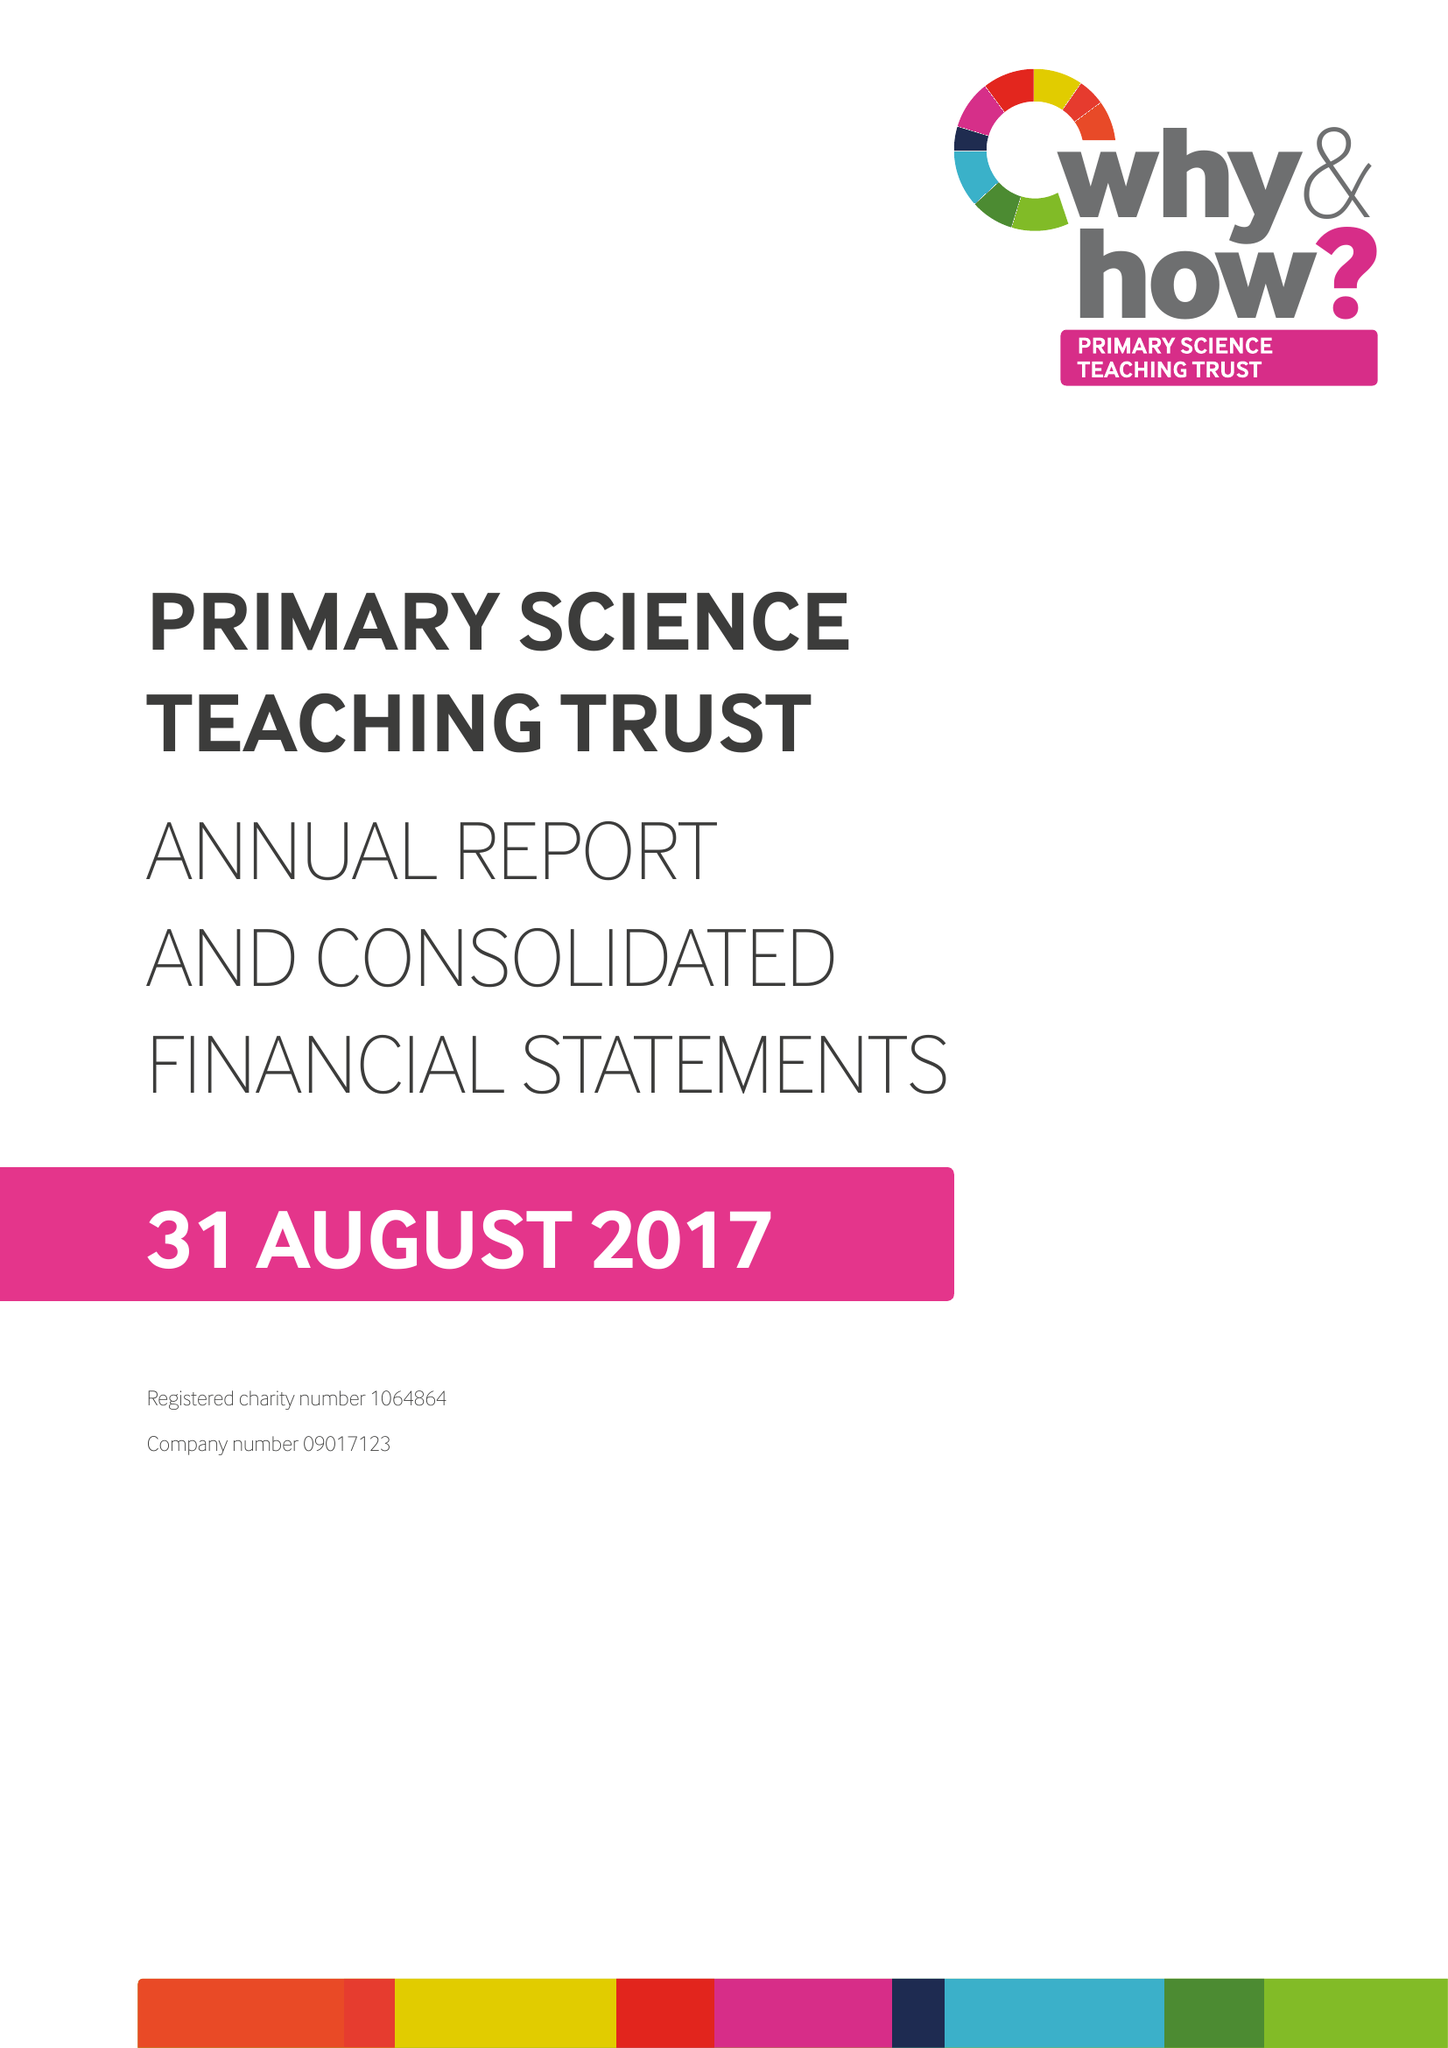What is the value for the income_annually_in_british_pounds?
Answer the question using a single word or phrase. 333528.00 